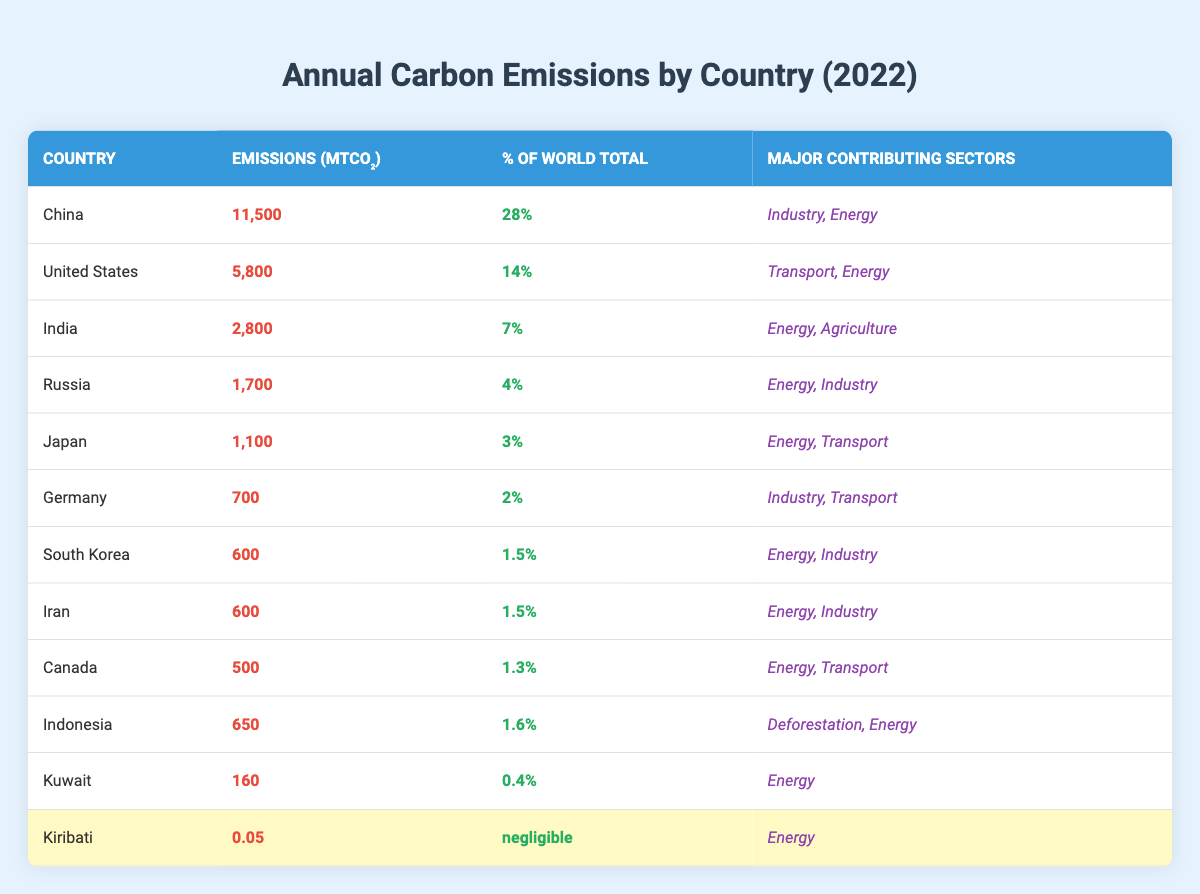What country has the highest annual carbon emissions? By examining the table, we see that China has the highest emissions at 11,500 MtCO2.
Answer: China What percentage of the world's total carbon emissions do the United States contribute? The table states that the United States contributes 14% of the world's total carbon emissions.
Answer: 14% Which country emits 0.05 MtCO₂ of carbon? Looking at the table, Kiribati is listed with emissions of 0.05 MtCO₂.
Answer: Kiribati What are the major contributing sectors for India's carbon emissions? From the table, India's major contributing sectors are identified as Energy and Agriculture.
Answer: Energy, Agriculture Which country has the smallest carbon emissions in this table? The emissions for Kiribati are 0.05 MtCO₂, which is the smallest listed in the table.
Answer: Kiribati How much carbon do Iran and South Korea emit combined? Iran emits 600 MtCO2 and South Korea also emits 600 MtCO2. The total emissions are 600 + 600 = 1200 MtCO2.
Answer: 1200 MtCO₂ Is Japan's percentage of world carbon emissions higher or lower than Germany's? Japan's emissions are at 3%, and Germany's are at 2%. Since 3% is greater than 2%, Japan's percentage is higher.
Answer: Higher What is the total carbon emissions from the top three emitters: China, the United States, and India? The emissions are 11,500 MtCO2 (China) + 5,800 MtCO2 (United States) + 2,800 MtCO2 (India). Adding these gives a total of 20,100 MtCO2.
Answer: 20,100 MtCO₂ Which country contributes the least percentage to the world's total emissions? Based on the table, Kiribati's contributions are labeled as "negligible," which is the least.
Answer: Kiribati If you compare Germany and Indonesia, which country emits more carbon? Germany has emissions of 700 MtCO2, while Indonesia has emissions of 650 MtCO2. Since 700 is greater than 650, Germany emits more carbon.
Answer: Germany 